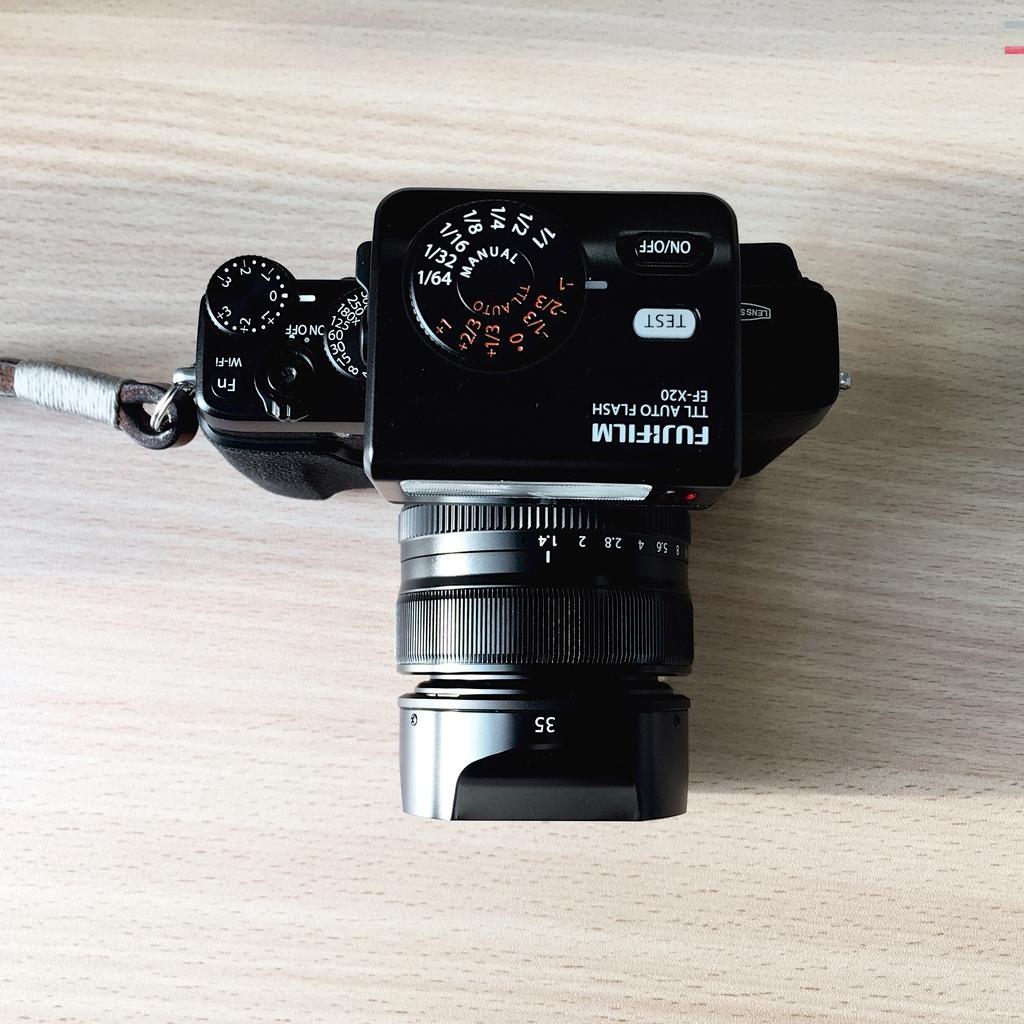Describe this image in one or two sentences. In this picture, we can see a camera on the wooden surface. 